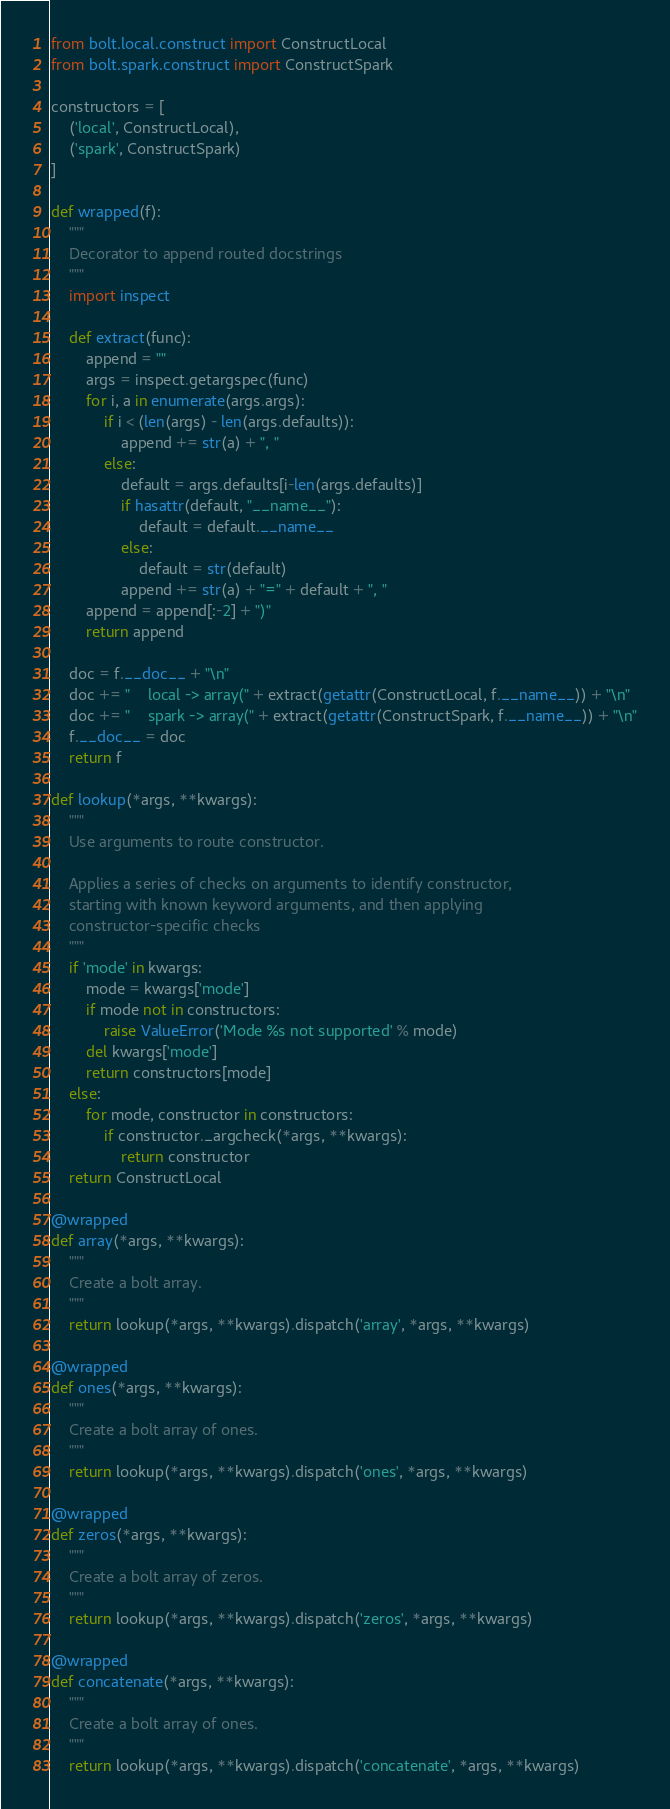<code> <loc_0><loc_0><loc_500><loc_500><_Python_>from bolt.local.construct import ConstructLocal
from bolt.spark.construct import ConstructSpark

constructors = [
    ('local', ConstructLocal),
    ('spark', ConstructSpark)
]

def wrapped(f):
    """
    Decorator to append routed docstrings
    """
    import inspect

    def extract(func):
        append = ""
        args = inspect.getargspec(func)
        for i, a in enumerate(args.args):
            if i < (len(args) - len(args.defaults)):
                append += str(a) + ", "
            else:
                default = args.defaults[i-len(args.defaults)]
                if hasattr(default, "__name__"):
                    default = default.__name__
                else:
                    default = str(default)
                append += str(a) + "=" + default + ", "
        append = append[:-2] + ")"
        return append

    doc = f.__doc__ + "\n"
    doc += "    local -> array(" + extract(getattr(ConstructLocal, f.__name__)) + "\n"
    doc += "    spark -> array(" + extract(getattr(ConstructSpark, f.__name__)) + "\n"
    f.__doc__ = doc
    return f

def lookup(*args, **kwargs):
    """
    Use arguments to route constructor.

    Applies a series of checks on arguments to identify constructor,
    starting with known keyword arguments, and then applying
    constructor-specific checks
    """
    if 'mode' in kwargs:
        mode = kwargs['mode']
        if mode not in constructors:
            raise ValueError('Mode %s not supported' % mode)
        del kwargs['mode']
        return constructors[mode]
    else:
        for mode, constructor in constructors:
            if constructor._argcheck(*args, **kwargs):
                return constructor
    return ConstructLocal

@wrapped
def array(*args, **kwargs):
    """
    Create a bolt array.
    """
    return lookup(*args, **kwargs).dispatch('array', *args, **kwargs)

@wrapped
def ones(*args, **kwargs):
    """
    Create a bolt array of ones.
    """
    return lookup(*args, **kwargs).dispatch('ones', *args, **kwargs)

@wrapped
def zeros(*args, **kwargs):
    """
    Create a bolt array of zeros.
    """
    return lookup(*args, **kwargs).dispatch('zeros', *args, **kwargs)

@wrapped
def concatenate(*args, **kwargs):
    """
    Create a bolt array of ones.
    """
    return lookup(*args, **kwargs).dispatch('concatenate', *args, **kwargs)</code> 